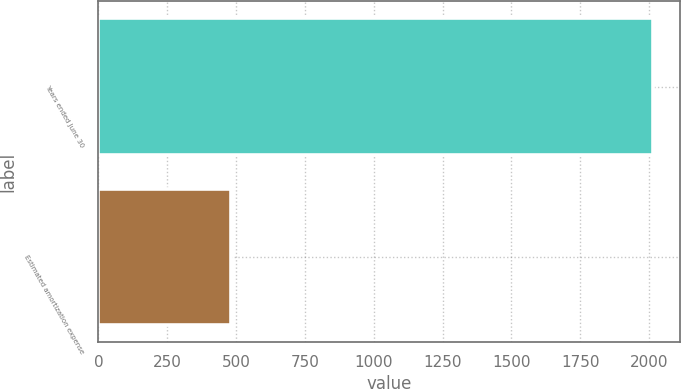<chart> <loc_0><loc_0><loc_500><loc_500><bar_chart><fcel>Years ended June 30<fcel>Estimated amortization expense<nl><fcel>2013<fcel>481<nl></chart> 